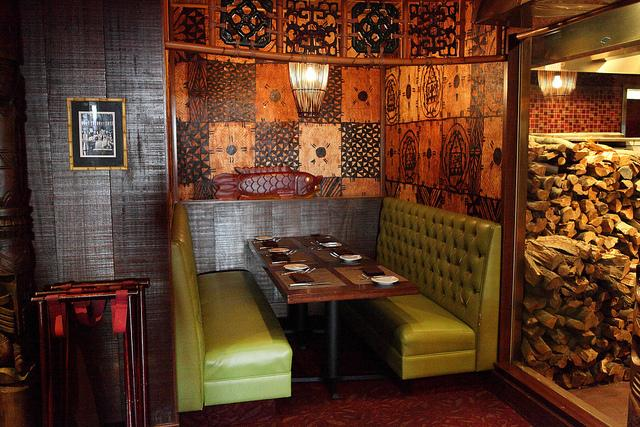How many people could fit comfortably in each booth?

Choices:
A) four
B) fifteen
C) eight
D) ten four 